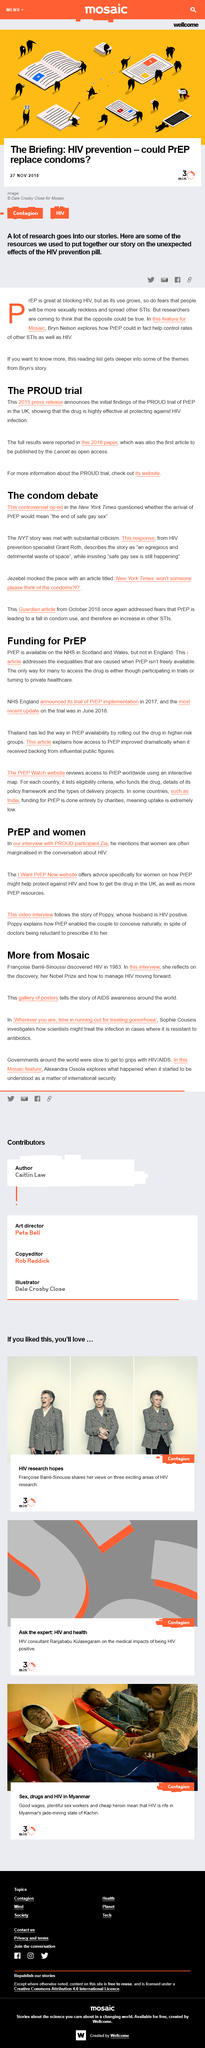Mention a couple of crucial points in this snapshot. Mosaic gallery's posters on AIDS awareness raised awareness globally about the story of AIDS. The video is about Poppy and her husband. Yes, Bryn Nelson explores the possibility that pre-exposure prophylaxis (PrEP) could help control rates of other sexually transmitted infections (STIs) as well as HIV. The website "I WANT PrEP NOW WEBSITE" is aimed at women. The op-ed regarding "the end of safe gay sex" is directly connected to the condom debate. 